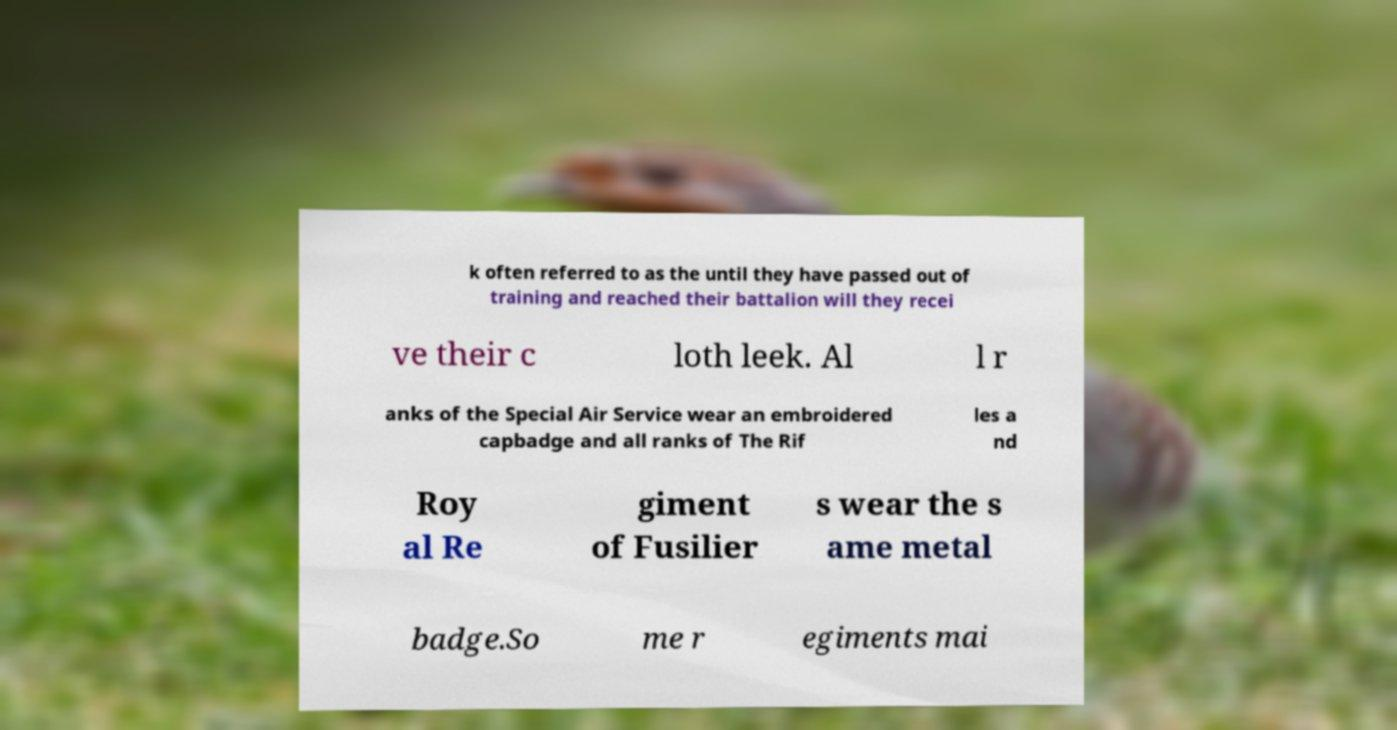Please identify and transcribe the text found in this image. k often referred to as the until they have passed out of training and reached their battalion will they recei ve their c loth leek. Al l r anks of the Special Air Service wear an embroidered capbadge and all ranks of The Rif les a nd Roy al Re giment of Fusilier s wear the s ame metal badge.So me r egiments mai 